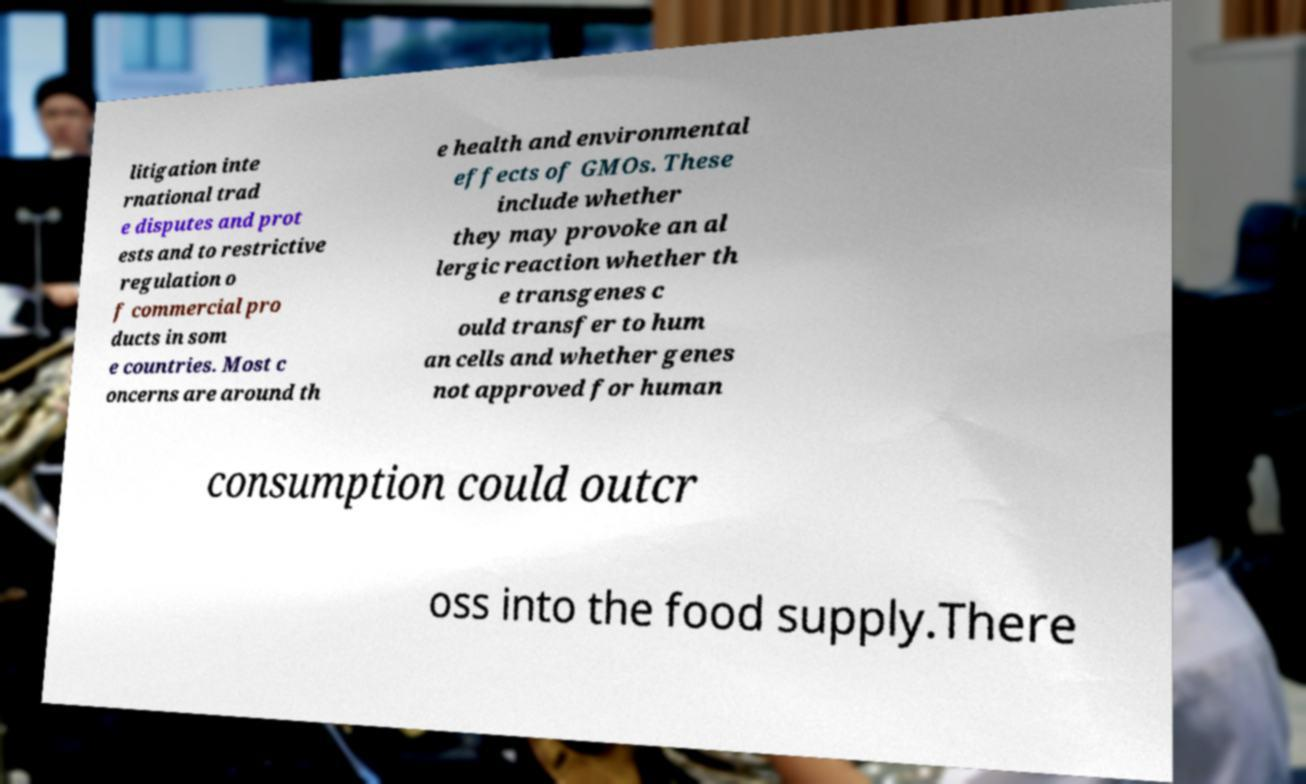Please read and relay the text visible in this image. What does it say? litigation inte rnational trad e disputes and prot ests and to restrictive regulation o f commercial pro ducts in som e countries. Most c oncerns are around th e health and environmental effects of GMOs. These include whether they may provoke an al lergic reaction whether th e transgenes c ould transfer to hum an cells and whether genes not approved for human consumption could outcr oss into the food supply.There 